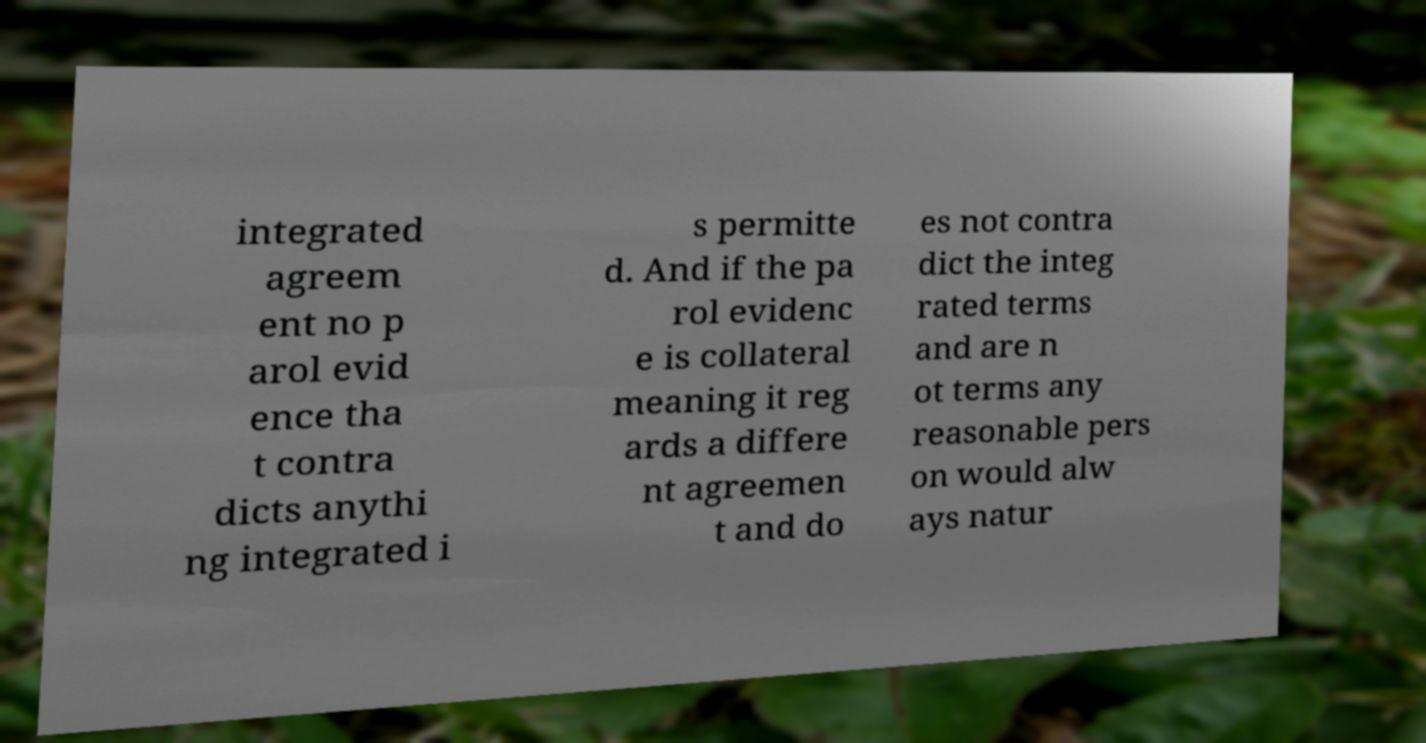There's text embedded in this image that I need extracted. Can you transcribe it verbatim? integrated agreem ent no p arol evid ence tha t contra dicts anythi ng integrated i s permitte d. And if the pa rol evidenc e is collateral meaning it reg ards a differe nt agreemen t and do es not contra dict the integ rated terms and are n ot terms any reasonable pers on would alw ays natur 